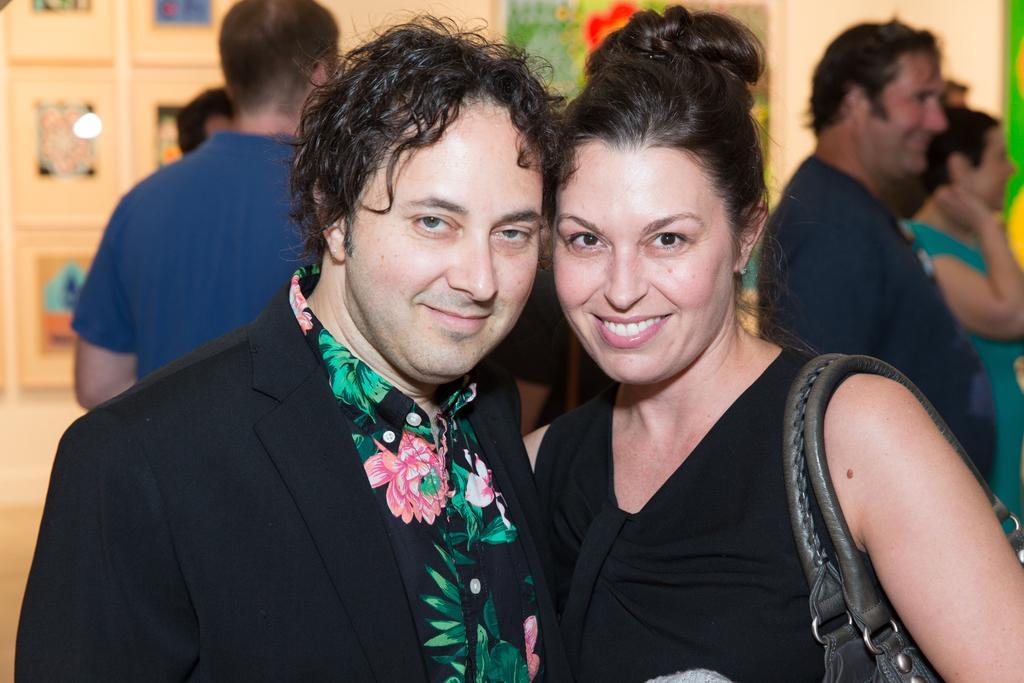Please provide a concise description of this image. In this image we can see a man and woman. They are wearing black color dress. Woman is holding bag. Behind them few people are there. 